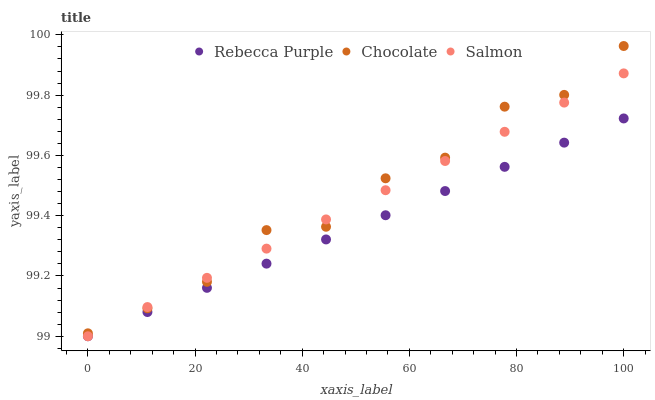Does Rebecca Purple have the minimum area under the curve?
Answer yes or no. Yes. Does Chocolate have the maximum area under the curve?
Answer yes or no. Yes. Does Chocolate have the minimum area under the curve?
Answer yes or no. No. Does Rebecca Purple have the maximum area under the curve?
Answer yes or no. No. Is Rebecca Purple the smoothest?
Answer yes or no. Yes. Is Chocolate the roughest?
Answer yes or no. Yes. Is Chocolate the smoothest?
Answer yes or no. No. Is Rebecca Purple the roughest?
Answer yes or no. No. Does Salmon have the lowest value?
Answer yes or no. Yes. Does Chocolate have the lowest value?
Answer yes or no. No. Does Chocolate have the highest value?
Answer yes or no. Yes. Does Rebecca Purple have the highest value?
Answer yes or no. No. Is Rebecca Purple less than Chocolate?
Answer yes or no. Yes. Is Chocolate greater than Rebecca Purple?
Answer yes or no. Yes. Does Salmon intersect Chocolate?
Answer yes or no. Yes. Is Salmon less than Chocolate?
Answer yes or no. No. Is Salmon greater than Chocolate?
Answer yes or no. No. Does Rebecca Purple intersect Chocolate?
Answer yes or no. No. 